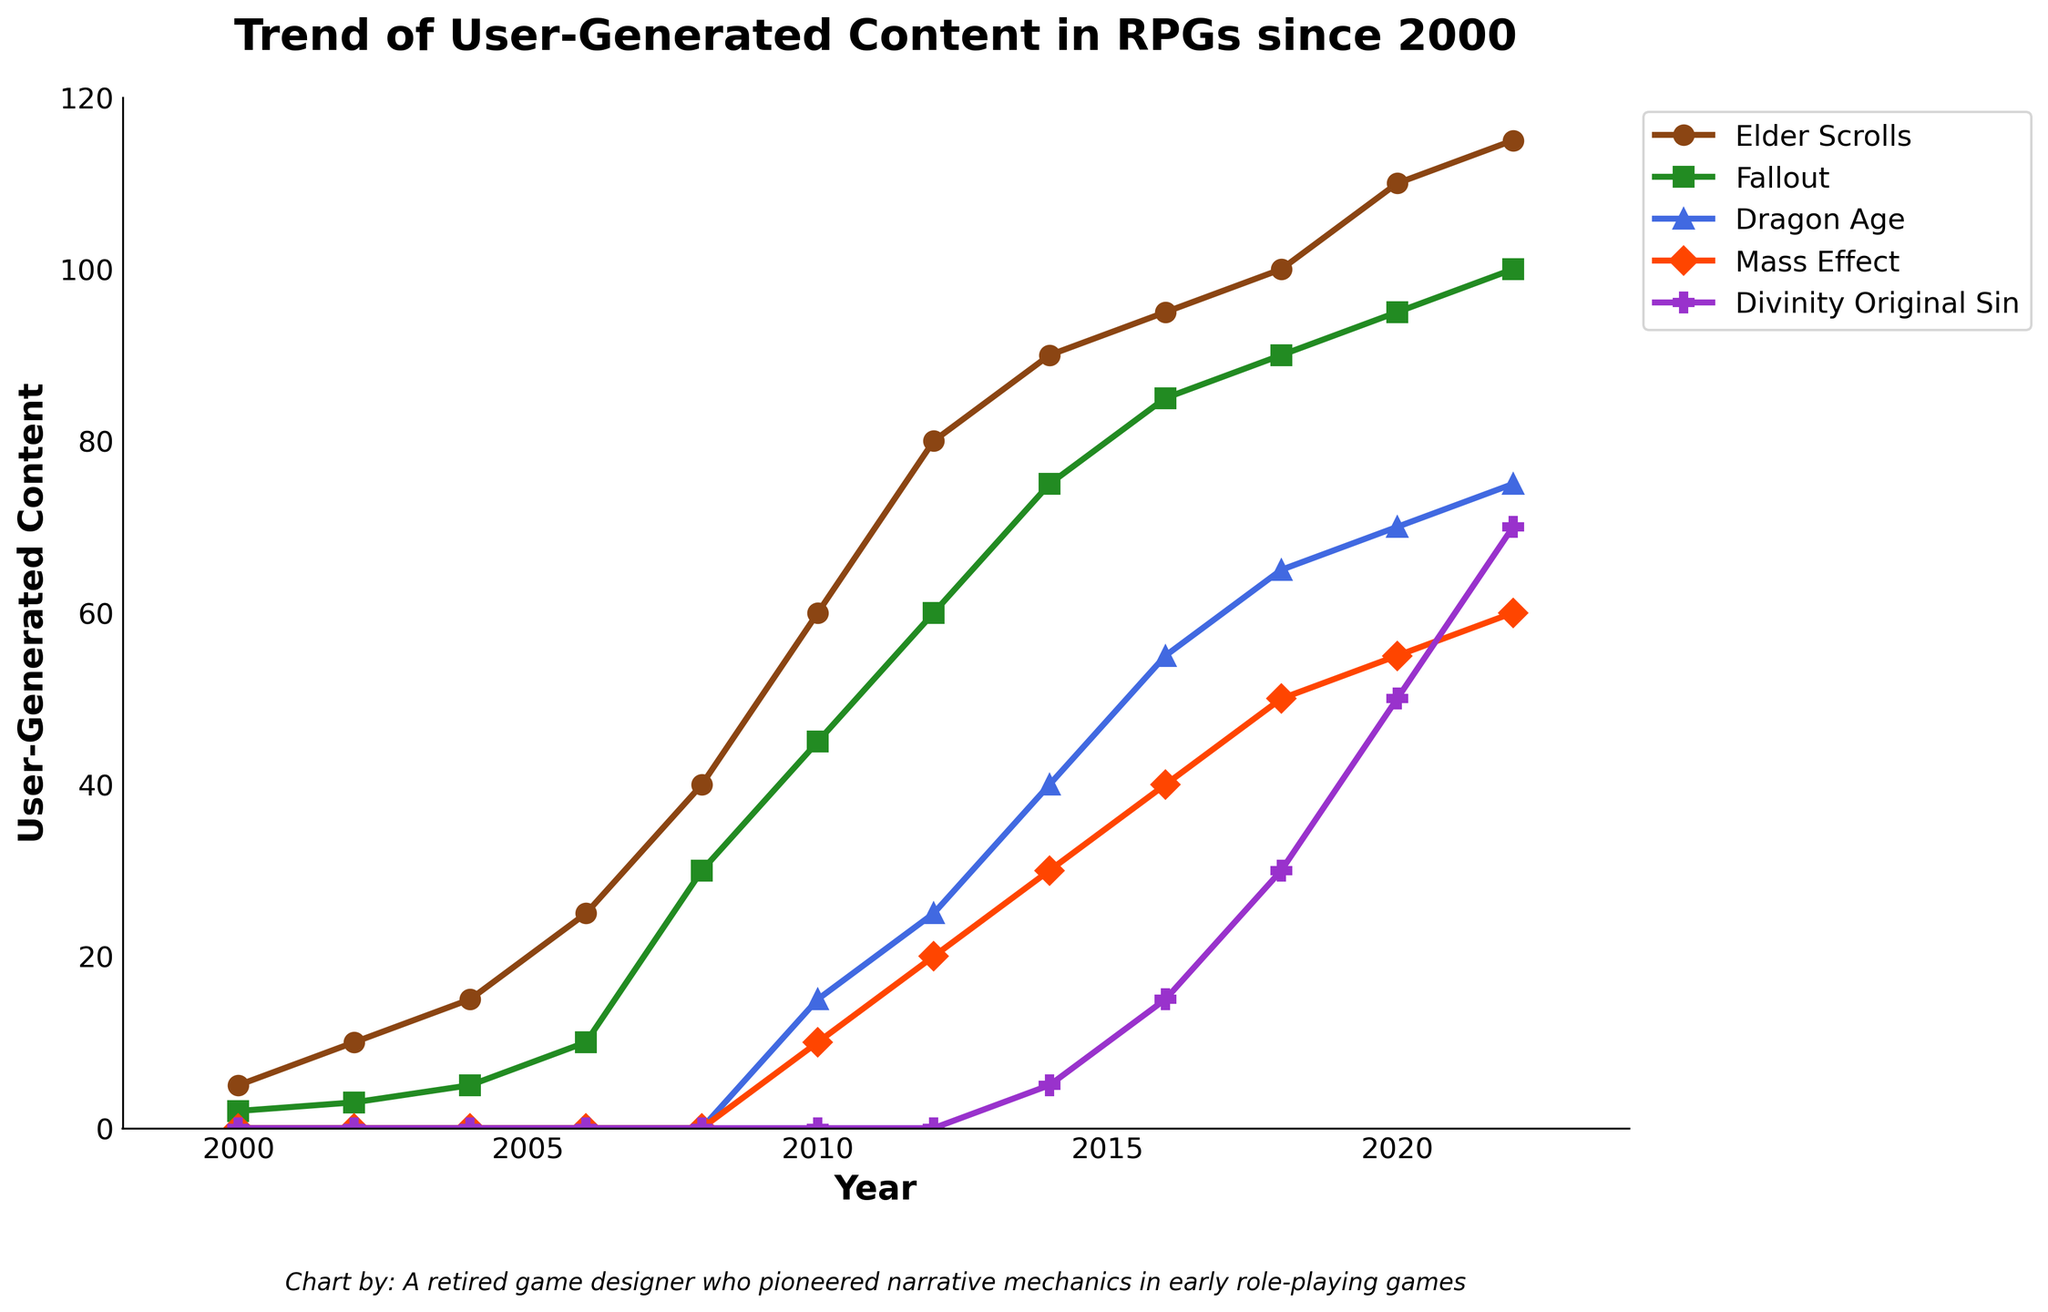Which franchise has the most user-generated content in 2022? Look for the year 2022 on the x-axis and check the y-axis values for each franchise. The highest value corresponds to the franchise with the most user-generated content. Elder Scrolls has 115, Fallout has 100, Dragon Age has 75, Mass Effect has 60, and Divinity Original Sin has 70.
Answer: Elder Scrolls Between 2010 and 2018, which franchise showed the highest increase in user-generated content? Calculate the increase for each franchise by subtracting the 2010 value from the 2018 value. Elder Scrolls: 100 - 60 = 40, Fallout: 90 - 45 = 45, Dragon Age: 65 - 15 = 50, Mass Effect: 50 - 10 = 40, Divinity Original Sin: 30 - 0 = 30. The highest increase is for Dragon Age with 50.
Answer: Dragon Age Compare the growth rates of Elder Scrolls and Fallout from 2000 to 2020. Which franchise grew more rapidly? Calculate the growth for each franchise by subtracting the 2000 value from the 2020 value. Elder Scrolls: 110 - 5 = 105, Fallout: 95 - 2 = 93. Elder Scrolls grew by 105 and Fallout by 93, so Elder Scrolls grew more rapidly.
Answer: Elder Scrolls What was the overall user-generated content for all franchises combined in 2014? Sum the user-generated content values for 2014 for all franchises. Elder Scrolls (90) + Fallout (75) + Dragon Age (40) + Mass Effect (30) + Divinity Original Sin (5) = 240.
Answer: 240 Which year did Divinity Original Sin first appear in the user-generated content data? Observe the x-axis and identify the year when Divinity Original Sin has a non-zero value. Divinity Original Sin first appears in 2014 with a value of 5.
Answer: 2014 Is there any year when the user-generated content for Mass Effect is equal to Dragon Age? Look for points where the values for Mass Effect and Dragon Age are the same. In 2008: Mass Effect is 10, Dragon Age is 0; in 2010: Mass Effect is 10, Dragon Age is 15; and similarly, in all other years, the values differ.
Answer: No Which franchise had the least user-generated content in 2006? Compare the y-axis values for each franchise for 2006. Elder Scrolls: 25, Fallout: 10, Dragon Age: 0, Mass Effect: 0, Divinity Original Sin: 0. Dragon Age, Mass Effect, and Divinity Original Sin all have 0, so they are the least.
Answer: Dragon Age, Mass Effect, Divinity Original Sin By what amount did the user-generated content for Fallout increase from 2008 to 2020? Subtract the 2008 value from the 2020 value for Fallout. 95 - 30 = 65. The user-generated content for Fallout increased by 65 from 2008 to 2020.
Answer: 65 How many franchises had user-generated content equal to or above 70 in 2020? Check the 2020 values for each franchise. Elder Scrolls: 110, Fallout: 95, Dragon Age: 70, Mass Effect: 55, Divinity Original Sin: 50. Elder Scrolls, Fallout, and Dragon Age are 70 or above. That's 3 franchises.
Answer: 3 